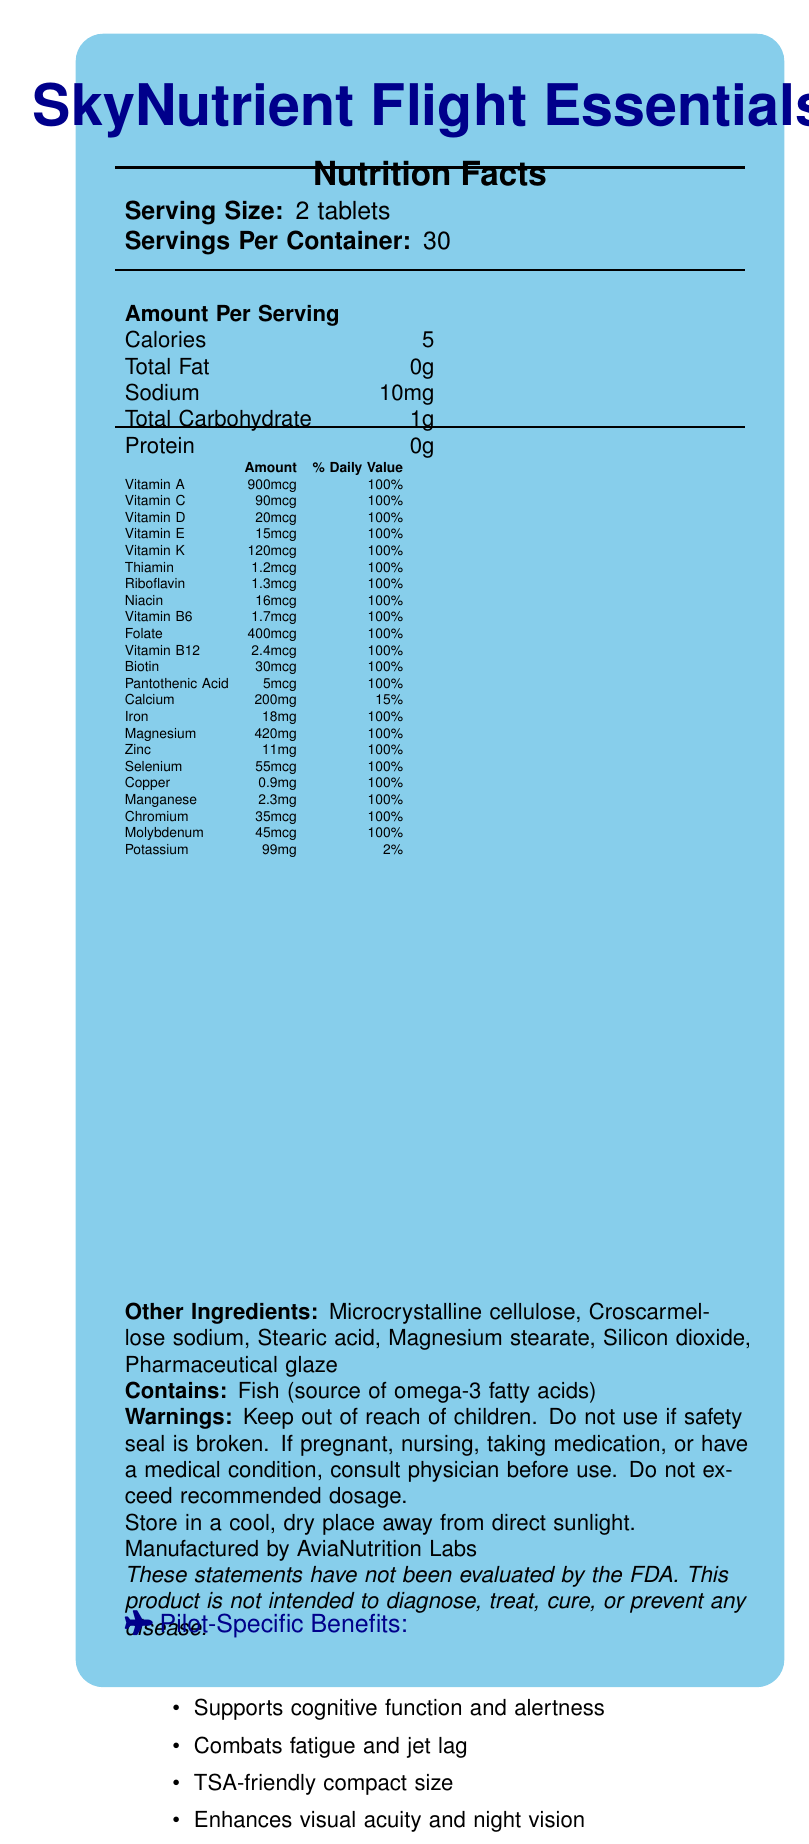How many servings are in one container of SkyNutrient Flight Essentials? The document states that there are 30 servings per container.
Answer: 30 What is the serving size for SkyNutrient Flight Essentials? The document specifies that the serving size is 2 tablets.
Answer: 2 tablets How many calories are in a serving of SkyNutrient Flight Essentials? The document lists that each serving contains 5 calories.
Answer: 5 What percentage of the daily value of Vitamin A is provided in one serving? According to the document, one serving provides 100% of the daily value for Vitamin A.
Answer: 100% What are the main minerals included in SkyNutrient Flight Essentials? The document lists these minerals in the Nutrition Facts section.
Answer: Calcium, Iron, Magnesium, Zinc, Selenium, Copper, Manganese, Chromium, Molybdenum, Potassium Which vitamins are present in amounts that meet 100% of their daily values? A. Vitamin A, Vitamin C, Folate B. Vitamin D, Vitamin B12, Calcium C. Vitamin E, Thiamin, Magnesium The document shows that Vitamin A, Vitamin C, and Folate each provide 100% of their daily value per serving, while Calcium does not.
Answer: A. Vitamin A, Vitamin C, Folate What is the total amount of vitamin B-complex present in one serving? A. 5.6 mcg B. 100 mcg C. 100 mg D. 100% of the daily value The document indicates that each B-vitamin (Thiamin, Riboflavin, Niacin, Vitamin B6, Folate, Vitamin B12, and Pantothenic Acid) is present in amounts equal to 100% of their daily values.
Answer: D. 100% of the daily value Does SkyNutrient Flight Essentials contain caffeine? The document lists caffeine with a value of 75 mg under the "Amount Per Serving" section.
Answer: Yes Is this product suitable for vegetarians? The document mentions that the supplement contains fish, which is the source of omega-3 fatty acids.
Answer: No What should be done if the safety seal is broken? The document contains a warning that advises not to use the product if the safety seal is broken.
Answer: Do not use What are the specific nutrients or components included to enhance visual acuity and night vision for pilots? The pilot-specific information section mentions Lutein and Zeaxanthin are included to support visual acuity and night vision.
Answer: Lutein and Zeaxanthin How are the ingredients listed under the "Other Ingredients" section commonly used in supplements? The document lists the other ingredients but does not provide information about their specific functions or common uses.
Answer: Not enough information Summarize the main features and benefits of SkyNutrient Flight Essentials. This description encompasses the product's purpose, the specific needs it addresses for pilots, the nutritional content, storage instructions, and safety warnings.
Answer: SkyNutrient Flight Essentials is a travel-sized vitamin and mineral supplement formulated specifically for pilots. Each serving is 2 tablets, with 30 servings per container. The supplement supports cognitive function and alertness, combats fatigue and jet lag, enhances visual acuity and night vision, and maintains proper hydration at high altitudes. It contains a mix of vitamins, minerals, omega-3 fatty acids, and other beneficial compounds, with most vitamins and minerals providing 100% of their daily values. The product is TSA-friendly and meets specific needs of pilots during long flights. It should be stored in a cool, dry place and kept out of children's reach. 